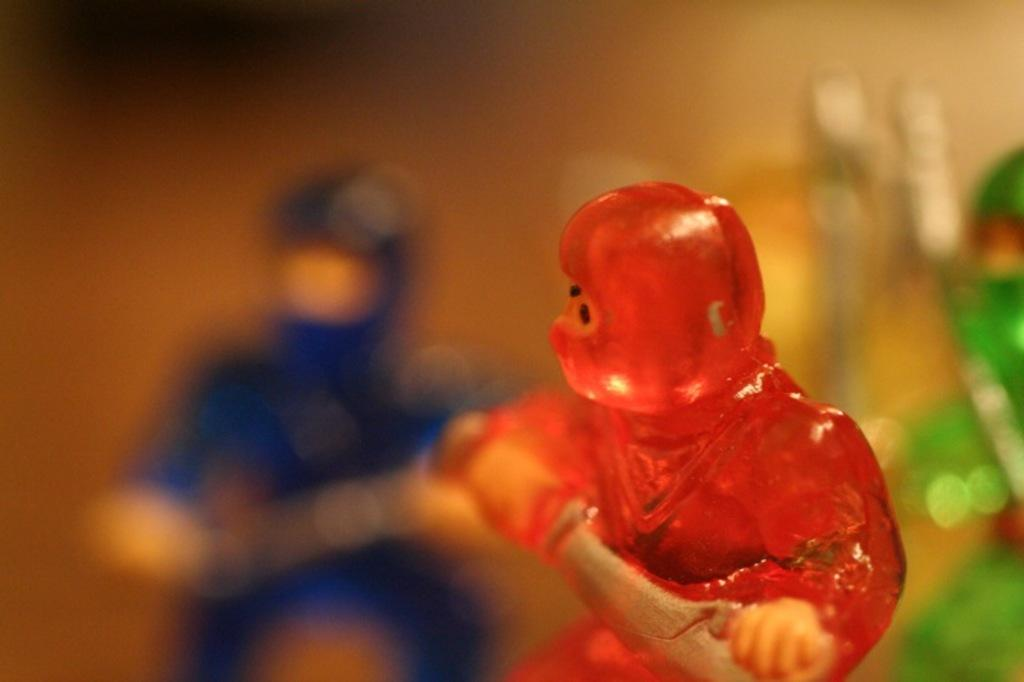What objects are present in the image? There are toys in the image. Can you describe the appearance of the toys? The toys have different colors. What can be observed about the background of the image? The background of the image is blurry. What type of hill can be seen in the background of the image? There is no hill present in the image; the background is blurry. Where is the lunchroom located in the image? There is no lunchroom present in the image; it features toys with different colors and a blurry background. 